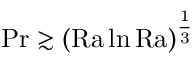<formula> <loc_0><loc_0><loc_500><loc_500>{ P r } \gtrsim ( \mathrm { R a } \ln \mathrm { R a } ) ^ { \frac { 1 } { 3 } }</formula> 